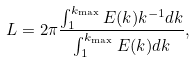Convert formula to latex. <formula><loc_0><loc_0><loc_500><loc_500>L = 2 \pi \frac { \int _ { 1 } ^ { k _ { \max } } { E ( k ) k ^ { - 1 } d k } } { \int _ { 1 } ^ { k _ { \max } } { E ( k ) d k } } ,</formula> 